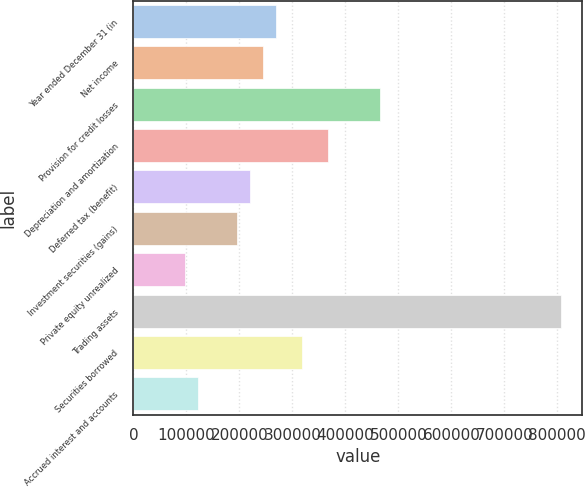Convert chart. <chart><loc_0><loc_0><loc_500><loc_500><bar_chart><fcel>Year ended December 31 (in<fcel>Net income<fcel>Provision for credit losses<fcel>Depreciation and amortization<fcel>Deferred tax (benefit)<fcel>Investment securities (gains)<fcel>Private equity unrealized<fcel>Trading assets<fcel>Securities borrowed<fcel>Accrued interest and accounts<nl><fcel>268994<fcel>244547<fcel>464574<fcel>366784<fcel>220100<fcel>195652<fcel>97862<fcel>806840<fcel>317890<fcel>122310<nl></chart> 